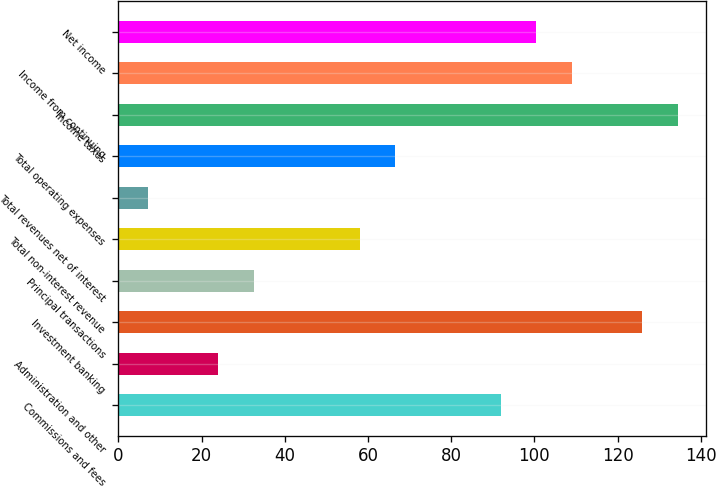<chart> <loc_0><loc_0><loc_500><loc_500><bar_chart><fcel>Commissions and fees<fcel>Administration and other<fcel>Investment banking<fcel>Principal transactions<fcel>Total non-interest revenue<fcel>Total revenues net of interest<fcel>Total operating expenses<fcel>Income taxes<fcel>Income from continuing<fcel>Net income<nl><fcel>92<fcel>24<fcel>126<fcel>32.5<fcel>58<fcel>7<fcel>66.5<fcel>134.5<fcel>109<fcel>100.5<nl></chart> 